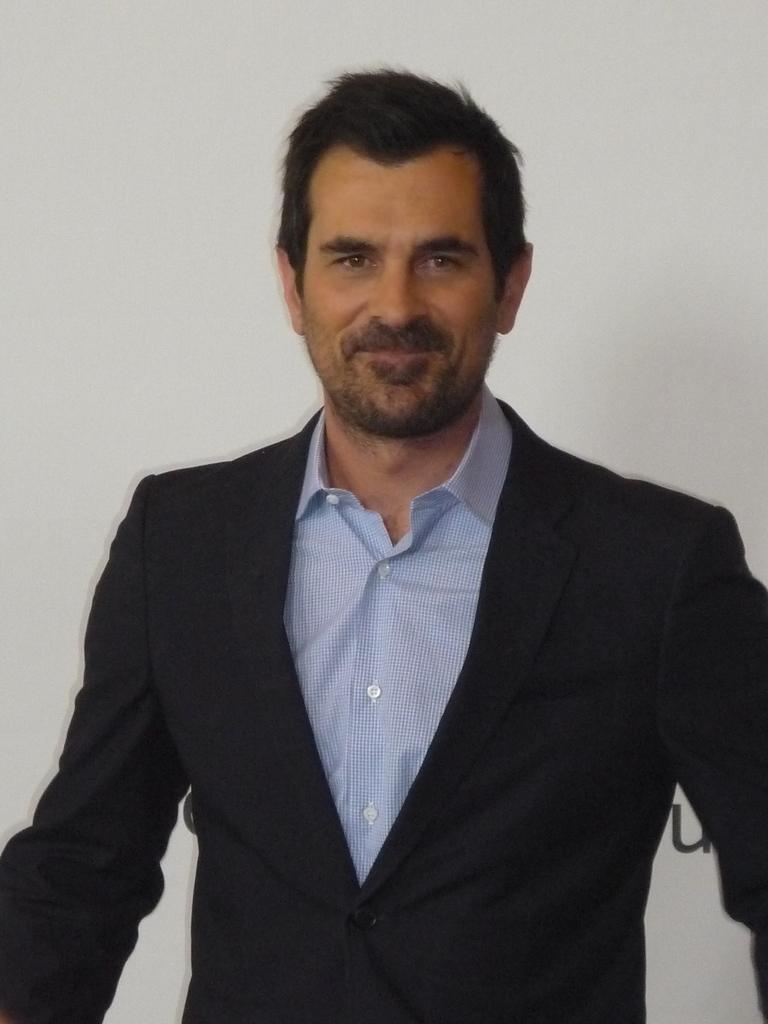In one or two sentences, can you explain what this image depicts? In this picture we can see a man smiling here, he wore a blazer, we can a wall in the background. 